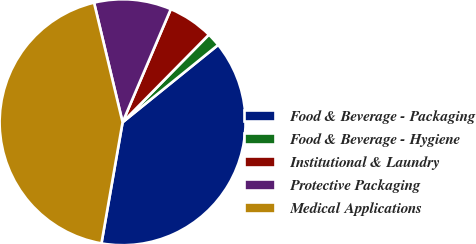<chart> <loc_0><loc_0><loc_500><loc_500><pie_chart><fcel>Food & Beverage - Packaging<fcel>Food & Beverage - Hygiene<fcel>Institutional & Laundry<fcel>Protective Packaging<fcel>Medical Applications<nl><fcel>38.58%<fcel>1.79%<fcel>5.97%<fcel>10.14%<fcel>43.52%<nl></chart> 